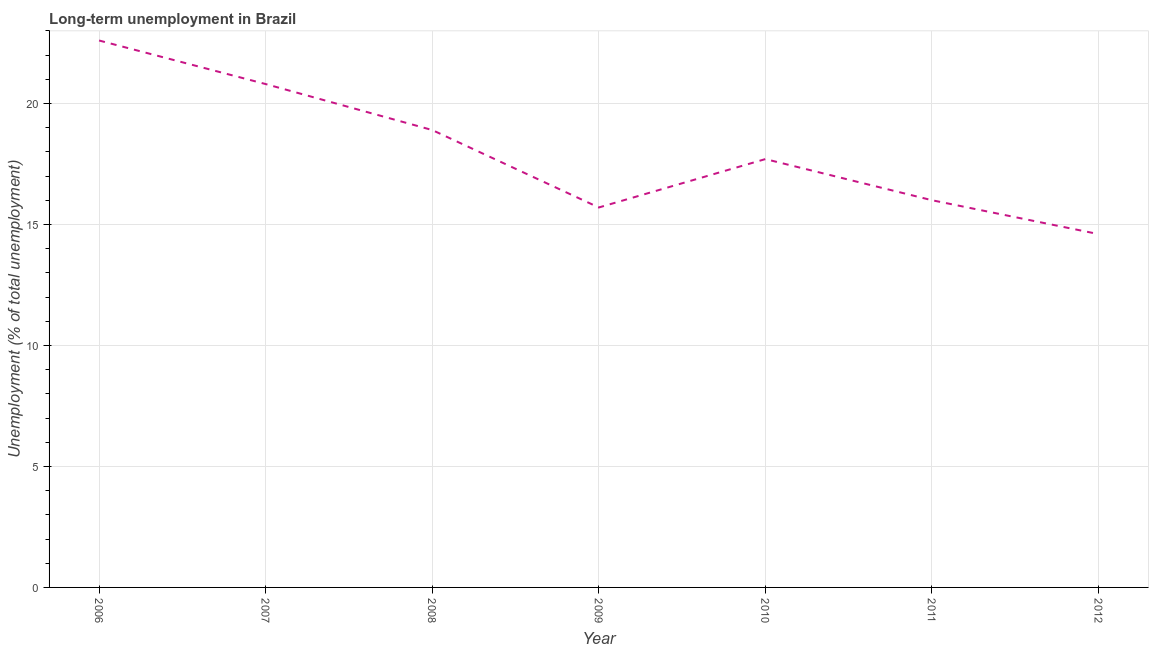What is the long-term unemployment in 2012?
Offer a very short reply. 14.6. Across all years, what is the maximum long-term unemployment?
Offer a terse response. 22.6. Across all years, what is the minimum long-term unemployment?
Your answer should be compact. 14.6. In which year was the long-term unemployment minimum?
Your answer should be compact. 2012. What is the sum of the long-term unemployment?
Keep it short and to the point. 126.3. What is the difference between the long-term unemployment in 2008 and 2011?
Offer a terse response. 2.9. What is the average long-term unemployment per year?
Make the answer very short. 18.04. What is the median long-term unemployment?
Ensure brevity in your answer.  17.7. In how many years, is the long-term unemployment greater than 12 %?
Make the answer very short. 7. What is the ratio of the long-term unemployment in 2010 to that in 2011?
Your response must be concise. 1.11. Is the long-term unemployment in 2006 less than that in 2010?
Offer a terse response. No. What is the difference between the highest and the second highest long-term unemployment?
Give a very brief answer. 1.8. Is the sum of the long-term unemployment in 2006 and 2007 greater than the maximum long-term unemployment across all years?
Offer a terse response. Yes. What is the difference between the highest and the lowest long-term unemployment?
Give a very brief answer. 8. How many lines are there?
Offer a very short reply. 1. How many years are there in the graph?
Make the answer very short. 7. What is the title of the graph?
Offer a terse response. Long-term unemployment in Brazil. What is the label or title of the Y-axis?
Your answer should be very brief. Unemployment (% of total unemployment). What is the Unemployment (% of total unemployment) of 2006?
Provide a short and direct response. 22.6. What is the Unemployment (% of total unemployment) of 2007?
Provide a short and direct response. 20.8. What is the Unemployment (% of total unemployment) of 2008?
Offer a terse response. 18.9. What is the Unemployment (% of total unemployment) of 2009?
Make the answer very short. 15.7. What is the Unemployment (% of total unemployment) of 2010?
Your response must be concise. 17.7. What is the Unemployment (% of total unemployment) of 2012?
Offer a terse response. 14.6. What is the difference between the Unemployment (% of total unemployment) in 2006 and 2007?
Your answer should be compact. 1.8. What is the difference between the Unemployment (% of total unemployment) in 2006 and 2008?
Offer a very short reply. 3.7. What is the difference between the Unemployment (% of total unemployment) in 2006 and 2011?
Make the answer very short. 6.6. What is the difference between the Unemployment (% of total unemployment) in 2007 and 2008?
Offer a very short reply. 1.9. What is the difference between the Unemployment (% of total unemployment) in 2007 and 2009?
Provide a succinct answer. 5.1. What is the difference between the Unemployment (% of total unemployment) in 2008 and 2009?
Ensure brevity in your answer.  3.2. What is the difference between the Unemployment (% of total unemployment) in 2008 and 2010?
Give a very brief answer. 1.2. What is the difference between the Unemployment (% of total unemployment) in 2008 and 2012?
Give a very brief answer. 4.3. What is the difference between the Unemployment (% of total unemployment) in 2010 and 2011?
Make the answer very short. 1.7. What is the ratio of the Unemployment (% of total unemployment) in 2006 to that in 2007?
Provide a short and direct response. 1.09. What is the ratio of the Unemployment (% of total unemployment) in 2006 to that in 2008?
Provide a short and direct response. 1.2. What is the ratio of the Unemployment (% of total unemployment) in 2006 to that in 2009?
Offer a terse response. 1.44. What is the ratio of the Unemployment (% of total unemployment) in 2006 to that in 2010?
Make the answer very short. 1.28. What is the ratio of the Unemployment (% of total unemployment) in 2006 to that in 2011?
Your response must be concise. 1.41. What is the ratio of the Unemployment (% of total unemployment) in 2006 to that in 2012?
Keep it short and to the point. 1.55. What is the ratio of the Unemployment (% of total unemployment) in 2007 to that in 2008?
Your response must be concise. 1.1. What is the ratio of the Unemployment (% of total unemployment) in 2007 to that in 2009?
Keep it short and to the point. 1.32. What is the ratio of the Unemployment (% of total unemployment) in 2007 to that in 2010?
Provide a succinct answer. 1.18. What is the ratio of the Unemployment (% of total unemployment) in 2007 to that in 2012?
Offer a terse response. 1.43. What is the ratio of the Unemployment (% of total unemployment) in 2008 to that in 2009?
Your answer should be very brief. 1.2. What is the ratio of the Unemployment (% of total unemployment) in 2008 to that in 2010?
Give a very brief answer. 1.07. What is the ratio of the Unemployment (% of total unemployment) in 2008 to that in 2011?
Your response must be concise. 1.18. What is the ratio of the Unemployment (% of total unemployment) in 2008 to that in 2012?
Keep it short and to the point. 1.29. What is the ratio of the Unemployment (% of total unemployment) in 2009 to that in 2010?
Your answer should be compact. 0.89. What is the ratio of the Unemployment (% of total unemployment) in 2009 to that in 2011?
Ensure brevity in your answer.  0.98. What is the ratio of the Unemployment (% of total unemployment) in 2009 to that in 2012?
Give a very brief answer. 1.07. What is the ratio of the Unemployment (% of total unemployment) in 2010 to that in 2011?
Ensure brevity in your answer.  1.11. What is the ratio of the Unemployment (% of total unemployment) in 2010 to that in 2012?
Offer a terse response. 1.21. What is the ratio of the Unemployment (% of total unemployment) in 2011 to that in 2012?
Provide a short and direct response. 1.1. 